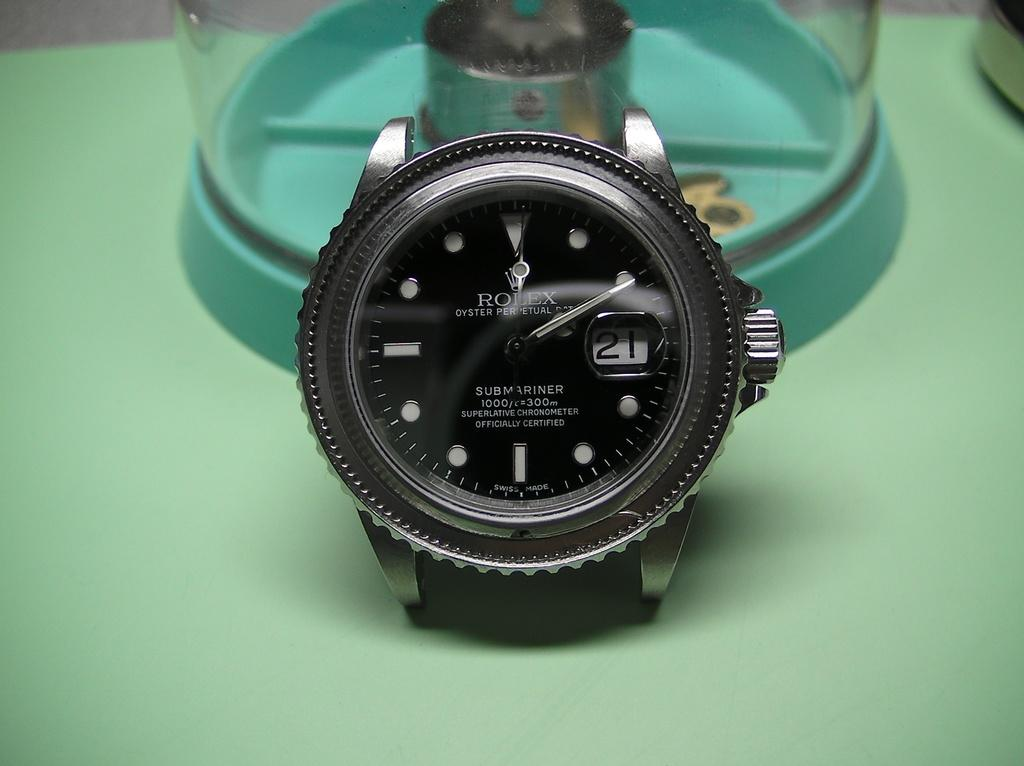<image>
Summarize the visual content of the image. The Rolex watch has a black face and the number 21 on it. 